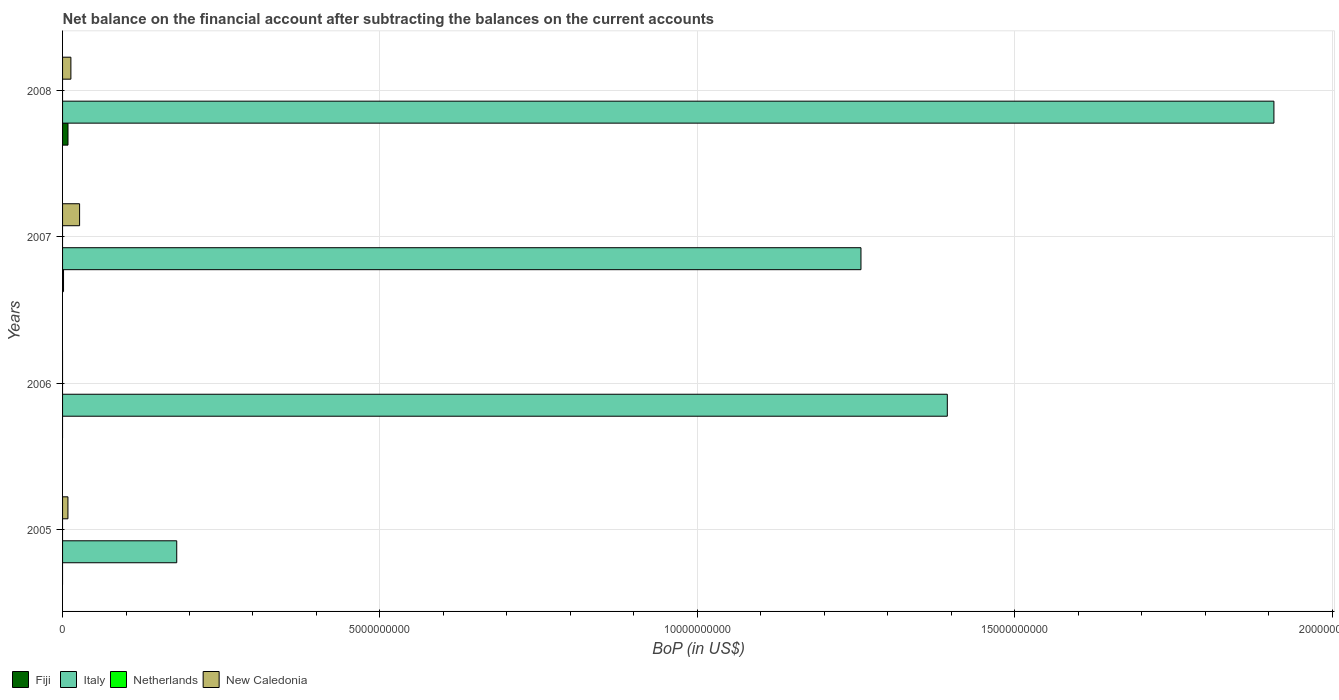How many bars are there on the 1st tick from the top?
Your response must be concise. 3. What is the Balance of Payments in Netherlands in 2005?
Provide a succinct answer. 0. Across all years, what is the maximum Balance of Payments in New Caledonia?
Your response must be concise. 2.68e+08. Across all years, what is the minimum Balance of Payments in New Caledonia?
Ensure brevity in your answer.  0. In which year was the Balance of Payments in Italy maximum?
Your response must be concise. 2008. What is the total Balance of Payments in Fiji in the graph?
Your answer should be compact. 1.01e+08. What is the difference between the Balance of Payments in New Caledonia in 2005 and that in 2007?
Your answer should be compact. -1.84e+08. What is the difference between the Balance of Payments in Italy in 2006 and the Balance of Payments in Netherlands in 2007?
Your answer should be very brief. 1.39e+1. What is the average Balance of Payments in Fiji per year?
Ensure brevity in your answer.  2.52e+07. What is the ratio of the Balance of Payments in Italy in 2005 to that in 2006?
Keep it short and to the point. 0.13. What is the difference between the highest and the second highest Balance of Payments in Italy?
Your response must be concise. 5.15e+09. What is the difference between the highest and the lowest Balance of Payments in Fiji?
Your answer should be very brief. 8.55e+07. In how many years, is the Balance of Payments in Italy greater than the average Balance of Payments in Italy taken over all years?
Provide a short and direct response. 3. Is it the case that in every year, the sum of the Balance of Payments in New Caledonia and Balance of Payments in Italy is greater than the sum of Balance of Payments in Netherlands and Balance of Payments in Fiji?
Your response must be concise. Yes. Is it the case that in every year, the sum of the Balance of Payments in Fiji and Balance of Payments in New Caledonia is greater than the Balance of Payments in Italy?
Provide a short and direct response. No. Are all the bars in the graph horizontal?
Provide a short and direct response. Yes. What is the difference between two consecutive major ticks on the X-axis?
Give a very brief answer. 5.00e+09. How are the legend labels stacked?
Your answer should be compact. Horizontal. What is the title of the graph?
Give a very brief answer. Net balance on the financial account after subtracting the balances on the current accounts. What is the label or title of the X-axis?
Your answer should be very brief. BoP (in US$). What is the label or title of the Y-axis?
Your answer should be very brief. Years. What is the BoP (in US$) in Italy in 2005?
Give a very brief answer. 1.80e+09. What is the BoP (in US$) in New Caledonia in 2005?
Provide a short and direct response. 8.45e+07. What is the BoP (in US$) in Fiji in 2006?
Make the answer very short. 0. What is the BoP (in US$) in Italy in 2006?
Your answer should be very brief. 1.39e+1. What is the BoP (in US$) of New Caledonia in 2006?
Keep it short and to the point. 0. What is the BoP (in US$) in Fiji in 2007?
Make the answer very short. 1.53e+07. What is the BoP (in US$) of Italy in 2007?
Offer a terse response. 1.26e+1. What is the BoP (in US$) of Netherlands in 2007?
Your answer should be very brief. 0. What is the BoP (in US$) of New Caledonia in 2007?
Your response must be concise. 2.68e+08. What is the BoP (in US$) in Fiji in 2008?
Provide a succinct answer. 8.55e+07. What is the BoP (in US$) of Italy in 2008?
Your response must be concise. 1.91e+1. What is the BoP (in US$) of Netherlands in 2008?
Your response must be concise. 0. What is the BoP (in US$) in New Caledonia in 2008?
Make the answer very short. 1.31e+08. Across all years, what is the maximum BoP (in US$) of Fiji?
Provide a succinct answer. 8.55e+07. Across all years, what is the maximum BoP (in US$) in Italy?
Your answer should be compact. 1.91e+1. Across all years, what is the maximum BoP (in US$) of New Caledonia?
Provide a short and direct response. 2.68e+08. Across all years, what is the minimum BoP (in US$) in Italy?
Ensure brevity in your answer.  1.80e+09. What is the total BoP (in US$) in Fiji in the graph?
Give a very brief answer. 1.01e+08. What is the total BoP (in US$) in Italy in the graph?
Provide a succinct answer. 4.74e+1. What is the total BoP (in US$) in New Caledonia in the graph?
Your answer should be compact. 4.84e+08. What is the difference between the BoP (in US$) in Italy in 2005 and that in 2006?
Your answer should be very brief. -1.21e+1. What is the difference between the BoP (in US$) in Italy in 2005 and that in 2007?
Offer a very short reply. -1.08e+1. What is the difference between the BoP (in US$) of New Caledonia in 2005 and that in 2007?
Keep it short and to the point. -1.84e+08. What is the difference between the BoP (in US$) of Italy in 2005 and that in 2008?
Provide a short and direct response. -1.73e+1. What is the difference between the BoP (in US$) of New Caledonia in 2005 and that in 2008?
Offer a terse response. -4.66e+07. What is the difference between the BoP (in US$) in Italy in 2006 and that in 2007?
Make the answer very short. 1.36e+09. What is the difference between the BoP (in US$) of Italy in 2006 and that in 2008?
Provide a succinct answer. -5.15e+09. What is the difference between the BoP (in US$) in Fiji in 2007 and that in 2008?
Provide a short and direct response. -7.03e+07. What is the difference between the BoP (in US$) of Italy in 2007 and that in 2008?
Offer a terse response. -6.51e+09. What is the difference between the BoP (in US$) in New Caledonia in 2007 and that in 2008?
Give a very brief answer. 1.37e+08. What is the difference between the BoP (in US$) in Italy in 2005 and the BoP (in US$) in New Caledonia in 2007?
Provide a succinct answer. 1.53e+09. What is the difference between the BoP (in US$) in Italy in 2005 and the BoP (in US$) in New Caledonia in 2008?
Offer a very short reply. 1.67e+09. What is the difference between the BoP (in US$) of Italy in 2006 and the BoP (in US$) of New Caledonia in 2007?
Provide a short and direct response. 1.37e+1. What is the difference between the BoP (in US$) of Italy in 2006 and the BoP (in US$) of New Caledonia in 2008?
Your response must be concise. 1.38e+1. What is the difference between the BoP (in US$) of Fiji in 2007 and the BoP (in US$) of Italy in 2008?
Keep it short and to the point. -1.91e+1. What is the difference between the BoP (in US$) of Fiji in 2007 and the BoP (in US$) of New Caledonia in 2008?
Your answer should be very brief. -1.16e+08. What is the difference between the BoP (in US$) in Italy in 2007 and the BoP (in US$) in New Caledonia in 2008?
Provide a succinct answer. 1.24e+1. What is the average BoP (in US$) of Fiji per year?
Your answer should be very brief. 2.52e+07. What is the average BoP (in US$) of Italy per year?
Your answer should be compact. 1.19e+1. What is the average BoP (in US$) in Netherlands per year?
Offer a very short reply. 0. What is the average BoP (in US$) of New Caledonia per year?
Your answer should be very brief. 1.21e+08. In the year 2005, what is the difference between the BoP (in US$) of Italy and BoP (in US$) of New Caledonia?
Provide a succinct answer. 1.71e+09. In the year 2007, what is the difference between the BoP (in US$) in Fiji and BoP (in US$) in Italy?
Your answer should be very brief. -1.26e+1. In the year 2007, what is the difference between the BoP (in US$) of Fiji and BoP (in US$) of New Caledonia?
Keep it short and to the point. -2.53e+08. In the year 2007, what is the difference between the BoP (in US$) of Italy and BoP (in US$) of New Caledonia?
Your answer should be compact. 1.23e+1. In the year 2008, what is the difference between the BoP (in US$) in Fiji and BoP (in US$) in Italy?
Your answer should be compact. -1.90e+1. In the year 2008, what is the difference between the BoP (in US$) of Fiji and BoP (in US$) of New Caledonia?
Your response must be concise. -4.56e+07. In the year 2008, what is the difference between the BoP (in US$) in Italy and BoP (in US$) in New Caledonia?
Offer a very short reply. 1.90e+1. What is the ratio of the BoP (in US$) of Italy in 2005 to that in 2006?
Your answer should be compact. 0.13. What is the ratio of the BoP (in US$) of Italy in 2005 to that in 2007?
Your answer should be very brief. 0.14. What is the ratio of the BoP (in US$) of New Caledonia in 2005 to that in 2007?
Give a very brief answer. 0.32. What is the ratio of the BoP (in US$) of Italy in 2005 to that in 2008?
Your answer should be very brief. 0.09. What is the ratio of the BoP (in US$) of New Caledonia in 2005 to that in 2008?
Make the answer very short. 0.64. What is the ratio of the BoP (in US$) of Italy in 2006 to that in 2007?
Make the answer very short. 1.11. What is the ratio of the BoP (in US$) in Italy in 2006 to that in 2008?
Provide a short and direct response. 0.73. What is the ratio of the BoP (in US$) in Fiji in 2007 to that in 2008?
Offer a very short reply. 0.18. What is the ratio of the BoP (in US$) of Italy in 2007 to that in 2008?
Your answer should be compact. 0.66. What is the ratio of the BoP (in US$) in New Caledonia in 2007 to that in 2008?
Provide a succinct answer. 2.04. What is the difference between the highest and the second highest BoP (in US$) in Italy?
Give a very brief answer. 5.15e+09. What is the difference between the highest and the second highest BoP (in US$) of New Caledonia?
Your response must be concise. 1.37e+08. What is the difference between the highest and the lowest BoP (in US$) in Fiji?
Provide a succinct answer. 8.55e+07. What is the difference between the highest and the lowest BoP (in US$) in Italy?
Your answer should be compact. 1.73e+1. What is the difference between the highest and the lowest BoP (in US$) of New Caledonia?
Your answer should be compact. 2.68e+08. 